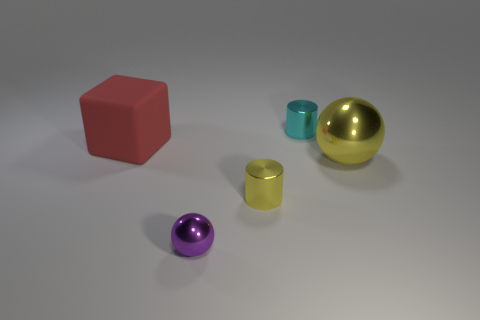Add 3 yellow rubber balls. How many objects exist? 8 Subtract all balls. How many objects are left? 3 Subtract 0 red cylinders. How many objects are left? 5 Subtract all tiny cyan cylinders. Subtract all large red things. How many objects are left? 3 Add 3 large red matte objects. How many large red matte objects are left? 4 Add 4 small purple shiny spheres. How many small purple shiny spheres exist? 5 